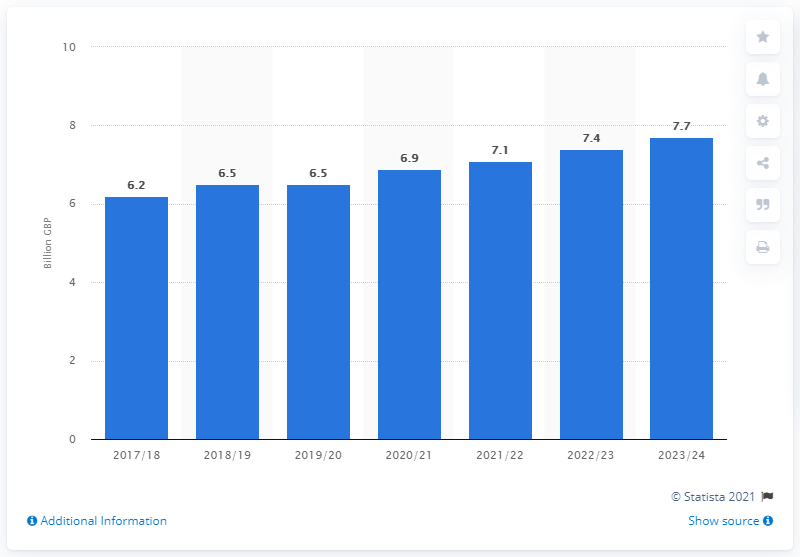Mention a couple of crucial points in this snapshot. The UK government anticipates receiving vehicle excise duties in the 2023/24 fiscal year. The amount of vehicle excise duties was expected to increase from 2017/18 to 2023/24 by 6.2%. The forecast increase in vehicle excise duties for the year 2023/24 is expected to be 7.7%. 